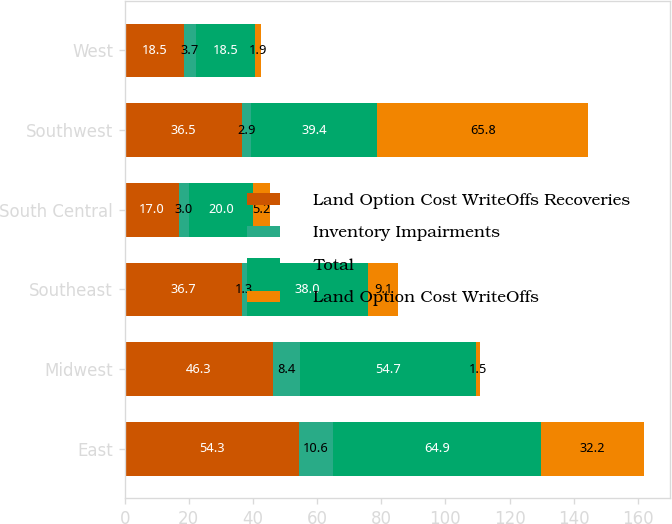<chart> <loc_0><loc_0><loc_500><loc_500><stacked_bar_chart><ecel><fcel>East<fcel>Midwest<fcel>Southeast<fcel>South Central<fcel>Southwest<fcel>West<nl><fcel>Land Option Cost WriteOffs Recoveries<fcel>54.3<fcel>46.3<fcel>36.7<fcel>17<fcel>36.5<fcel>18.5<nl><fcel>Inventory Impairments<fcel>10.6<fcel>8.4<fcel>1.3<fcel>3<fcel>2.9<fcel>3.7<nl><fcel>Total<fcel>64.9<fcel>54.7<fcel>38<fcel>20<fcel>39.4<fcel>18.5<nl><fcel>Land Option Cost WriteOffs<fcel>32.2<fcel>1.5<fcel>9.1<fcel>5.2<fcel>65.8<fcel>1.9<nl></chart> 